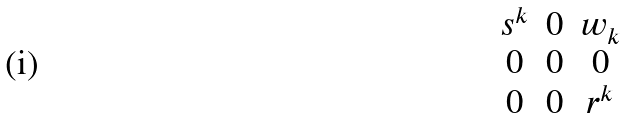<formula> <loc_0><loc_0><loc_500><loc_500>\begin{matrix} s ^ { k } & 0 & w _ { k } \\ 0 & 0 & 0 \\ 0 & 0 & r ^ { k } \end{matrix}</formula> 